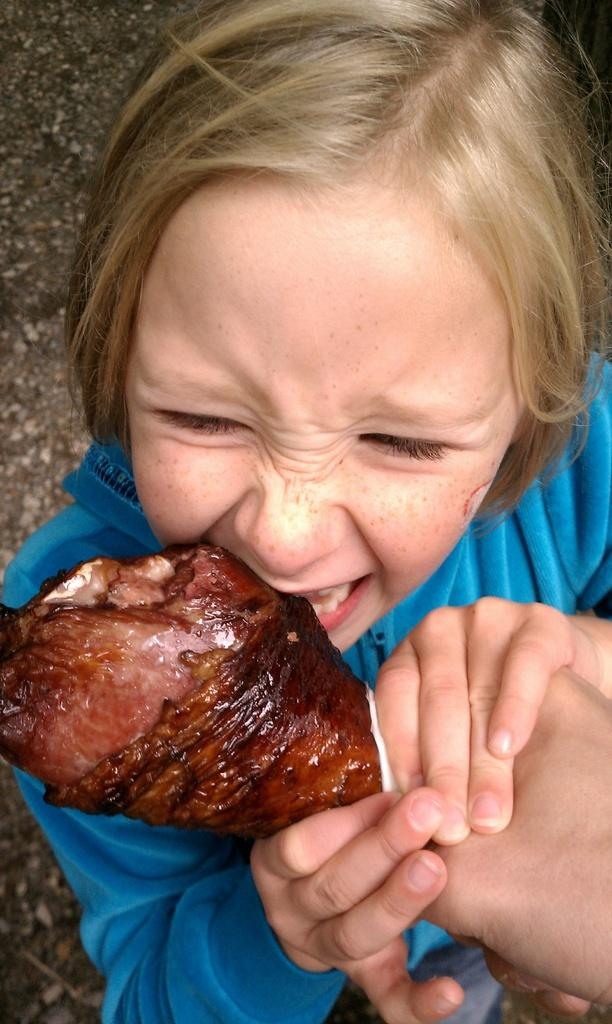What is the main subject of the image? The main subject of the image is a girl. What is the girl doing in the image? The girl is eating a food item. Who is holding the food item that the girl is eating? The food item is being held by another person's hand. How many cherries can be seen in the vase in the image? There is no vase or cherries present in the image. What type of farming equipment can be seen in the image? There is no farming equipment present in the image. 